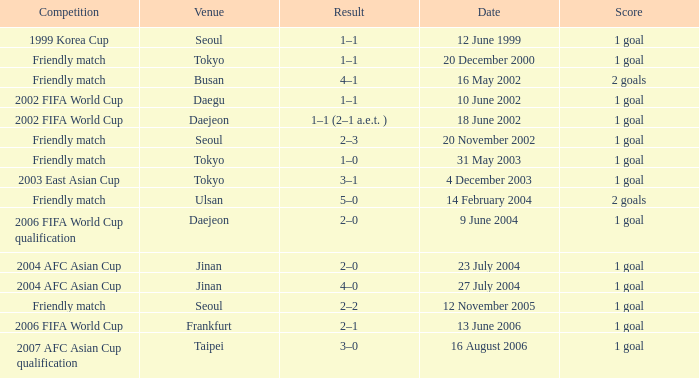What is the competition that occured on 27 July 2004? 2004 AFC Asian Cup. 